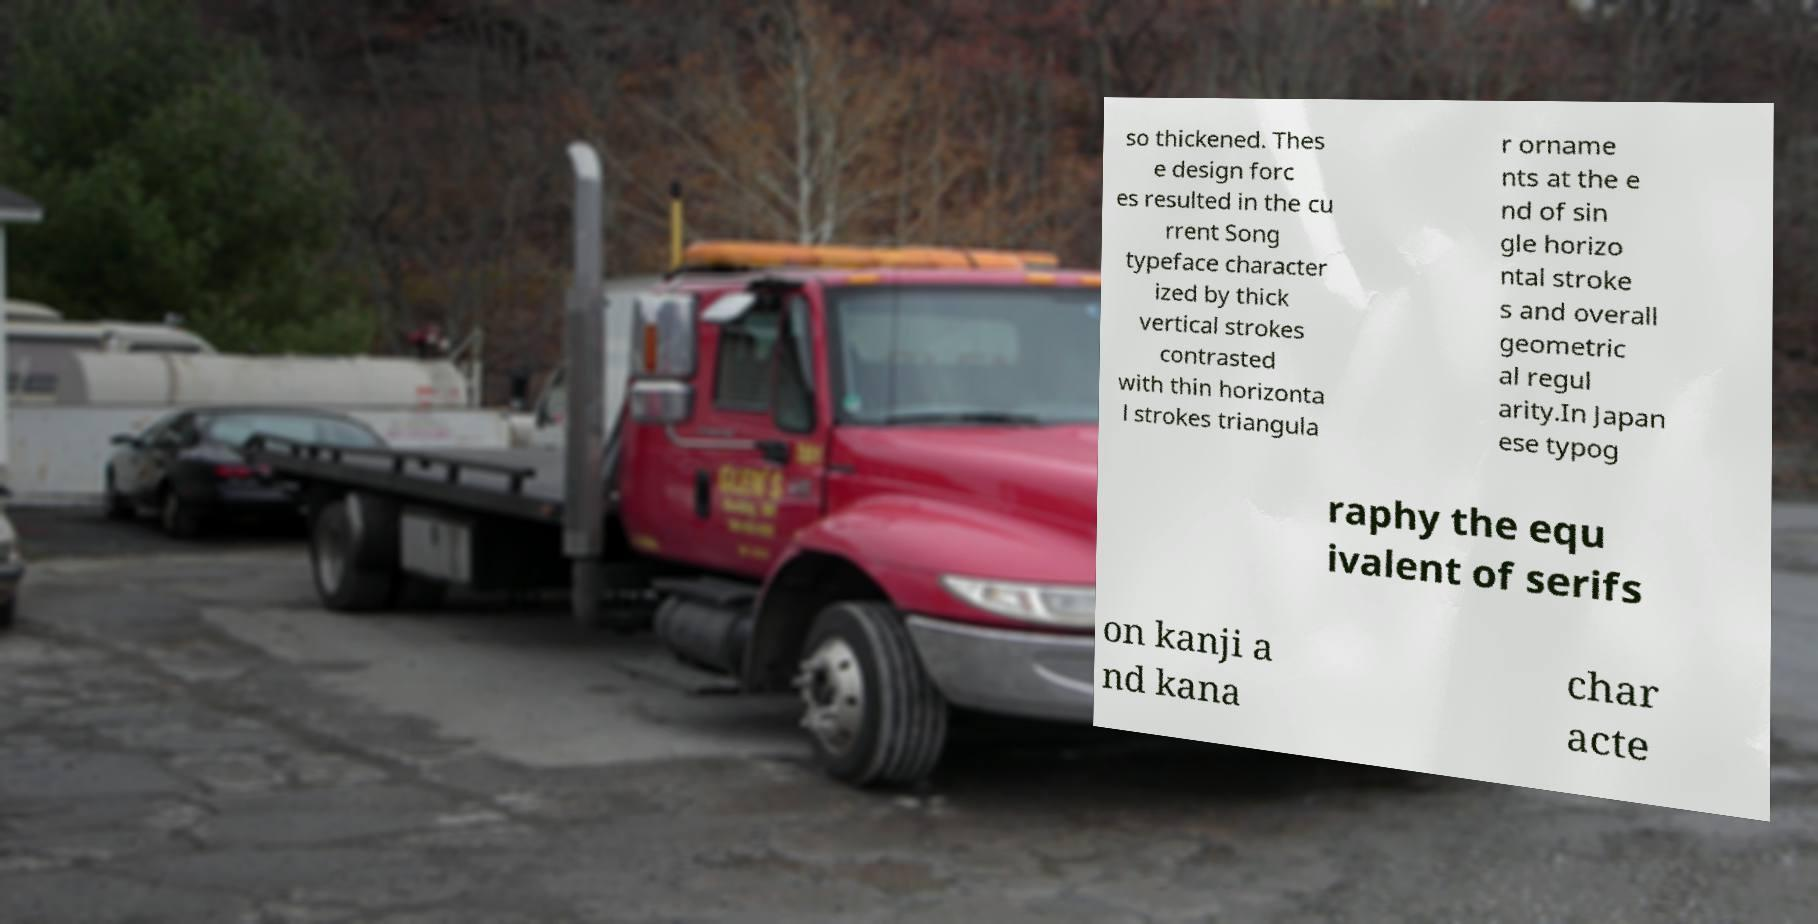I need the written content from this picture converted into text. Can you do that? so thickened. Thes e design forc es resulted in the cu rrent Song typeface character ized by thick vertical strokes contrasted with thin horizonta l strokes triangula r orname nts at the e nd of sin gle horizo ntal stroke s and overall geometric al regul arity.In Japan ese typog raphy the equ ivalent of serifs on kanji a nd kana char acte 